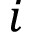<formula> <loc_0><loc_0><loc_500><loc_500>i</formula> 